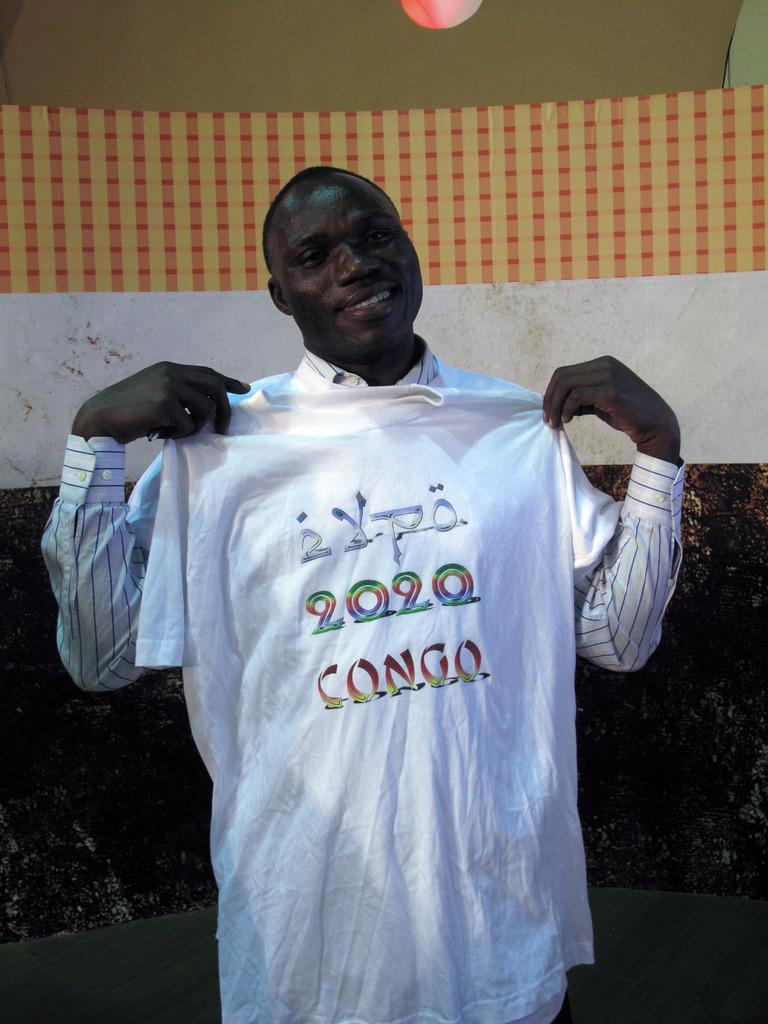<image>
Describe the image concisely. A man holds up a white tshirt that says Expo 2020 Congo 